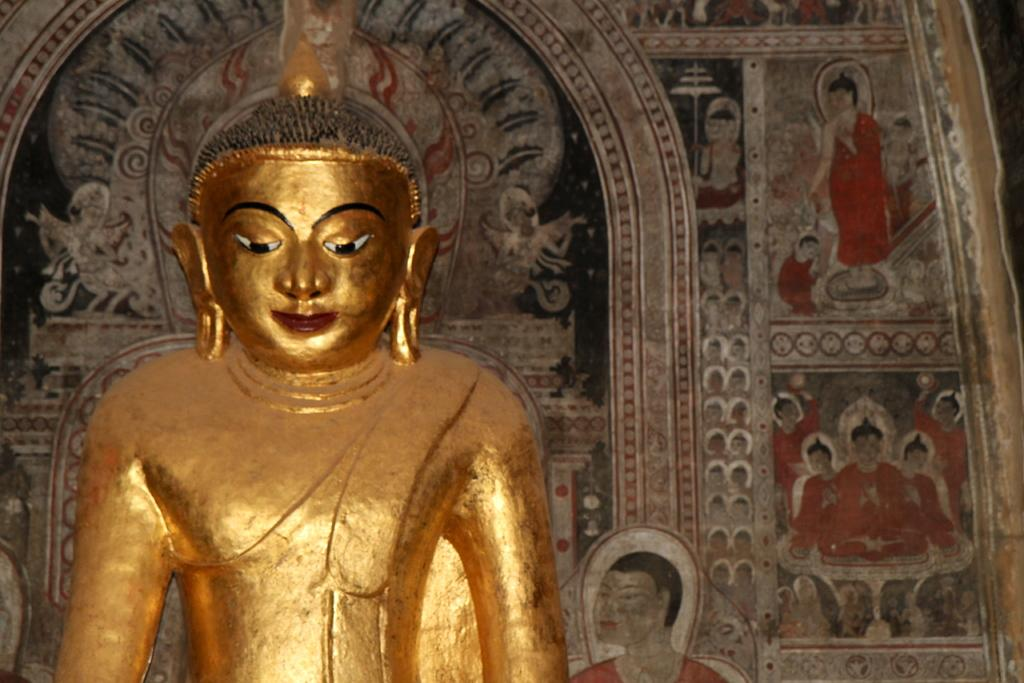What is the main subject of the image? There is a sculpture of Gautama Buddha in the image. What can be seen behind the sculpture? There is a wall behind the sculpture. What decorations are on the wall? There are paintings on the wall. Can you see a crown on the head of the sculpture in the image? No, there is no crown visible on the head of the sculpture in the image. 